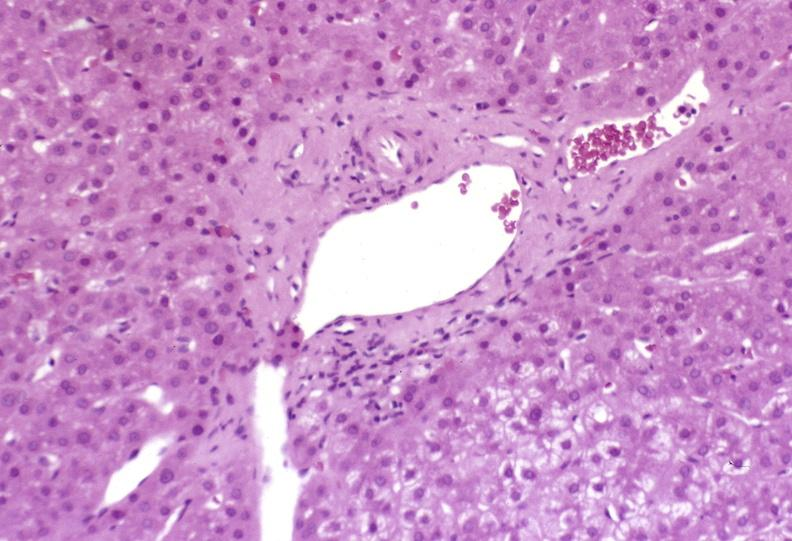does that show mild-to-moderate acute rejection?
Answer the question using a single word or phrase. No 